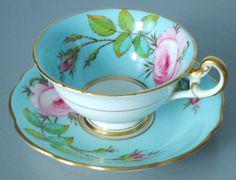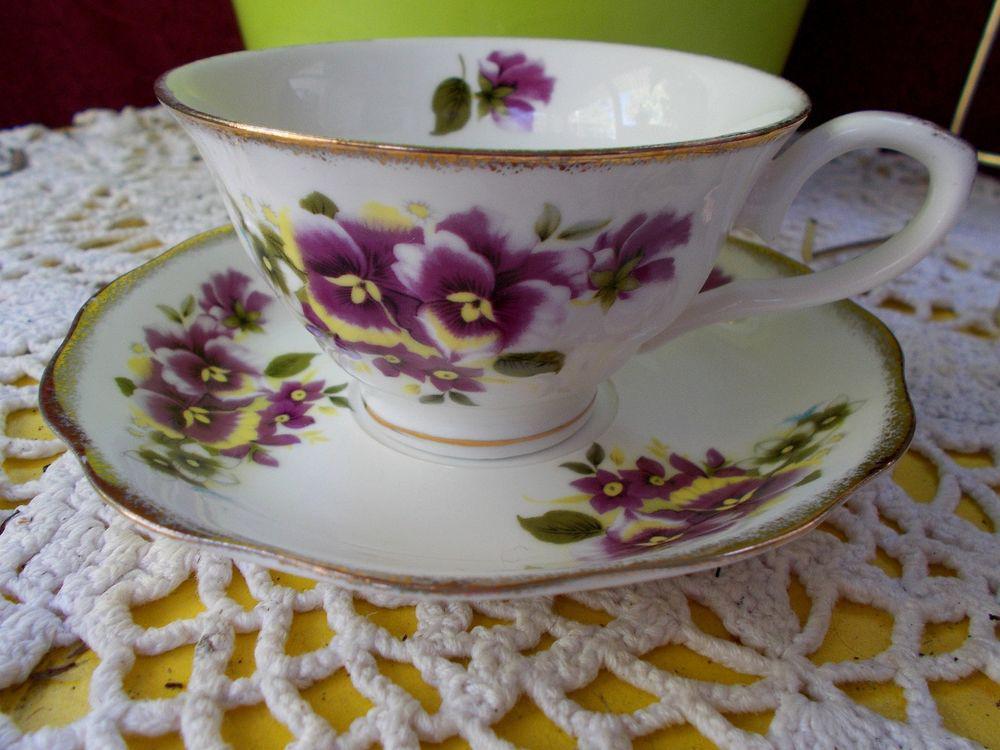The first image is the image on the left, the second image is the image on the right. For the images shown, is this caption "One of the teacups is blue with pink flowers on it." true? Answer yes or no. Yes. 